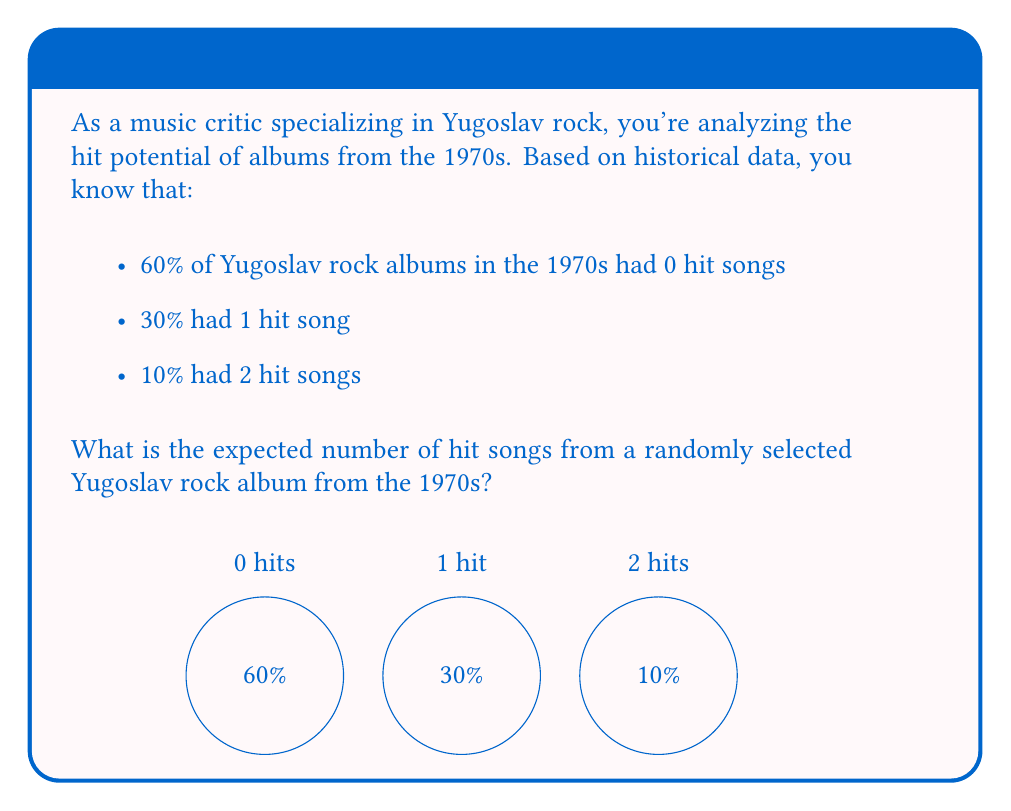Can you solve this math problem? To calculate the expected value, we need to multiply each possible outcome by its probability and sum the results. Let's break it down step-by-step:

1. Define the random variable $X$ as the number of hit songs on an album.

2. List the probabilities for each outcome:
   $P(X=0) = 0.60$
   $P(X=1) = 0.30$
   $P(X=2) = 0.10$

3. Calculate the expected value using the formula:
   $$E(X) = \sum_{i=0}^{n} x_i \cdot P(X=x_i)$$

4. Plug in the values:
   $$E(X) = 0 \cdot 0.60 + 1 \cdot 0.30 + 2 \cdot 0.10$$

5. Simplify:
   $$E(X) = 0 + 0.30 + 0.20 = 0.50$$

Therefore, the expected number of hit songs from a randomly selected Yugoslav rock album from the 1970s is 0.50 or 1/2.
Answer: 0.50 hit songs 